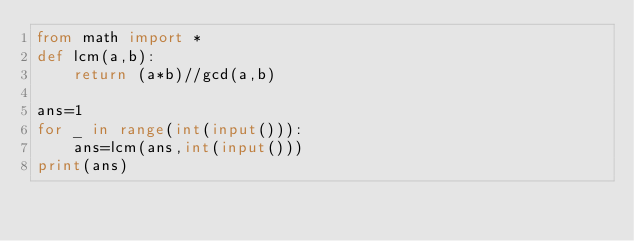Convert code to text. <code><loc_0><loc_0><loc_500><loc_500><_Python_>from math import * 
def lcm(a,b):
    return (a*b)//gcd(a,b)

ans=1
for _ in range(int(input())):
    ans=lcm(ans,int(input()))
print(ans)</code> 